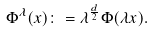Convert formula to latex. <formula><loc_0><loc_0><loc_500><loc_500>\Phi ^ { \lambda } ( x ) \colon = \lambda ^ { \frac { d } { 2 } } \Phi ( \lambda x ) .</formula> 